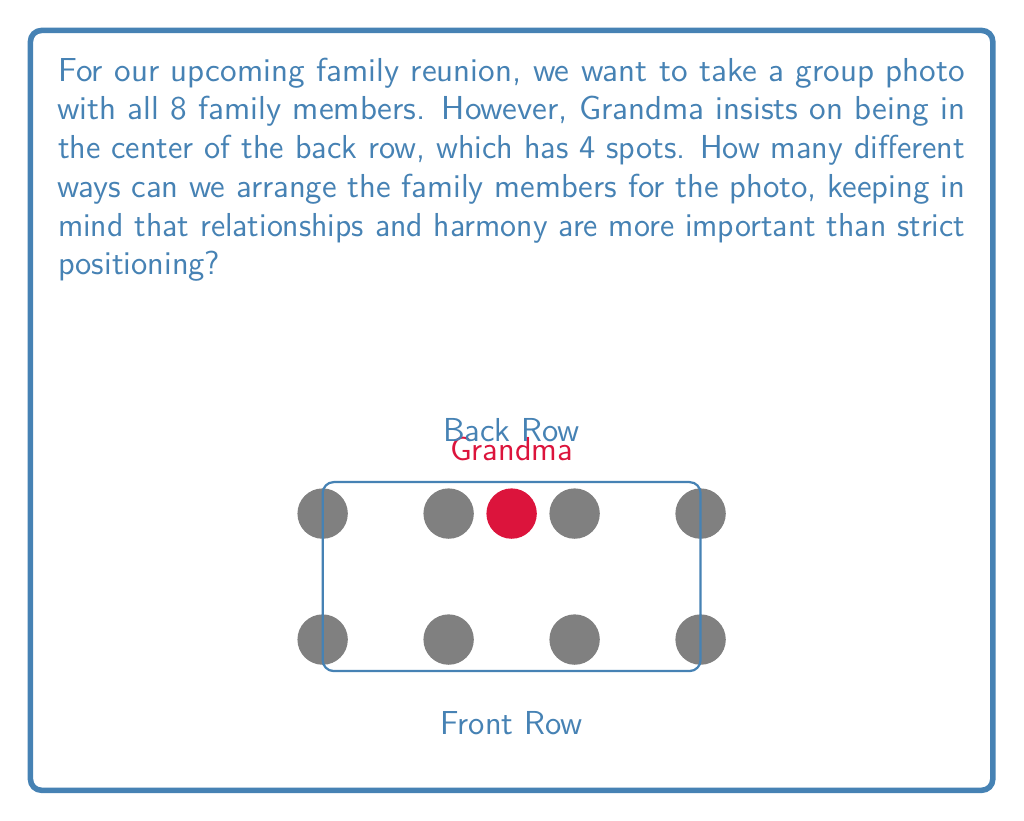Show me your answer to this math problem. Let's approach this step-by-step, keeping in mind that our goal is to maintain family harmony while solving this problem:

1) We have 8 family members in total, with Grandma's position fixed in the center of the back row.

2) This leaves 7 family members to be arranged in the remaining 7 positions.

3) To calculate the number of ways to arrange 7 people in 7 positions, we use the concept of permutations. The formula for this is:

   $$P(7,7) = 7!$$

4) Calculating 7!:
   $$7! = 7 \times 6 \times 5 \times 4 \times 3 \times 2 \times 1 = 5040$$

5) Therefore, there are 5040 different ways to arrange the family members.

Remember, while this number represents the mathematical possibilities, the most important aspect is that everyone feels included and comfortable in the photo, regardless of their exact position.
Answer: $5040$ ways 